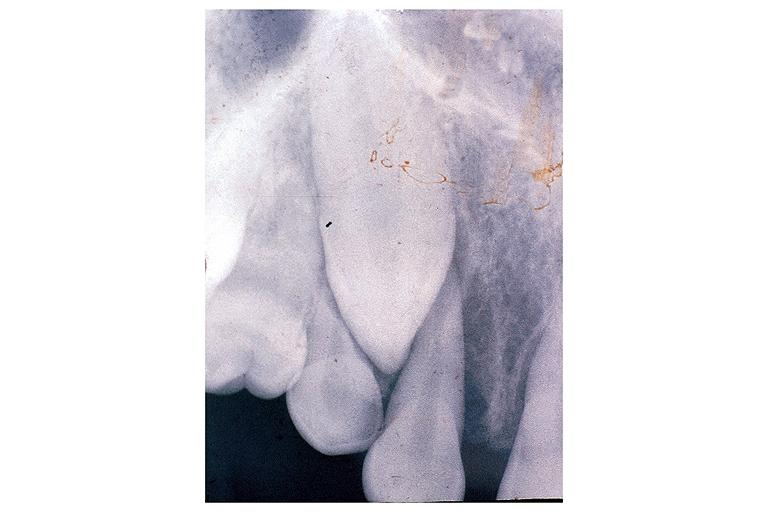does angiogram saphenous vein bypass graft show osteosarcoma?
Answer the question using a single word or phrase. No 